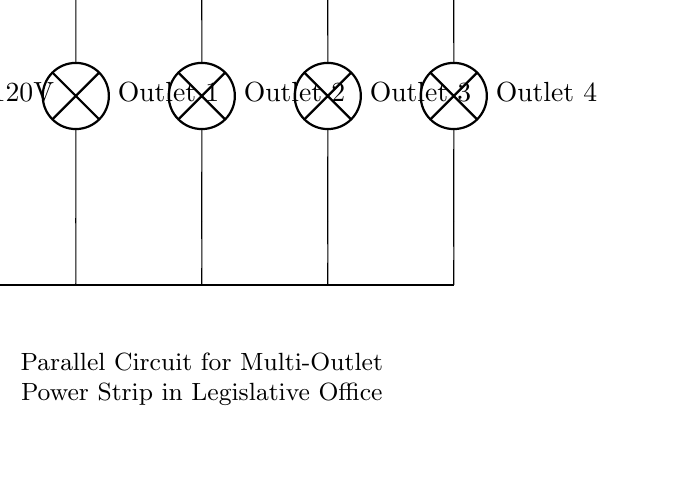What is the total voltage in this circuit? The circuit shows a voltage source labeled as 120V connected to the power strip, indicating that the entire circuit operates at this voltage.
Answer: 120 volts How many outlets are in the circuit? The diagram displays four distinct outlets, each indicated by a lamp symbol.
Answer: Four What type of circuit is this? The arrangement of the outlets is such that they are all connected in parallel to the voltage source, which is characteristic of a parallel circuit configuration.
Answer: Parallel What does each outlet represent in terms of current? Since this is a parallel circuit, each outlet will be provided with the same voltage of 120V, but the total current will be shared among the four outlets according to their individual resistances.
Answer: Shared current What happens to the current if one outlet is disconnected? In a parallel circuit, disconnecting one outlet does not affect the others, as each remains connected independently to the voltage source. This means the other outlets would continue to function normally while the one is disconnected.
Answer: Others continue functioning What is the significance of the short lines in the diagram? The short lines represent direct connections between the components in the circuit and indicate that the components are electrically connected, allowing current to pass through them without resistance.
Answer: Direct connections 